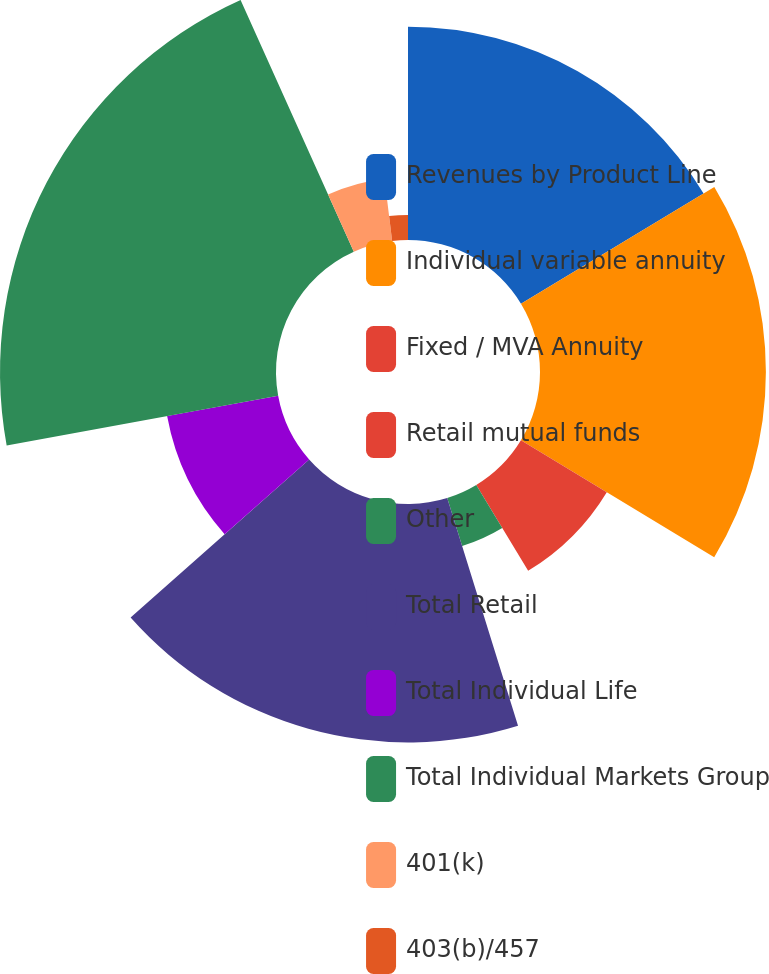Convert chart. <chart><loc_0><loc_0><loc_500><loc_500><pie_chart><fcel>Revenues by Product Line<fcel>Individual variable annuity<fcel>Fixed / MVA Annuity<fcel>Retail mutual funds<fcel>Other<fcel>Total Retail<fcel>Total Individual Life<fcel>Total Individual Markets Group<fcel>401(k)<fcel>403(b)/457<nl><fcel>16.35%<fcel>17.31%<fcel>0.0%<fcel>7.69%<fcel>3.85%<fcel>18.27%<fcel>8.65%<fcel>21.15%<fcel>4.81%<fcel>1.92%<nl></chart> 